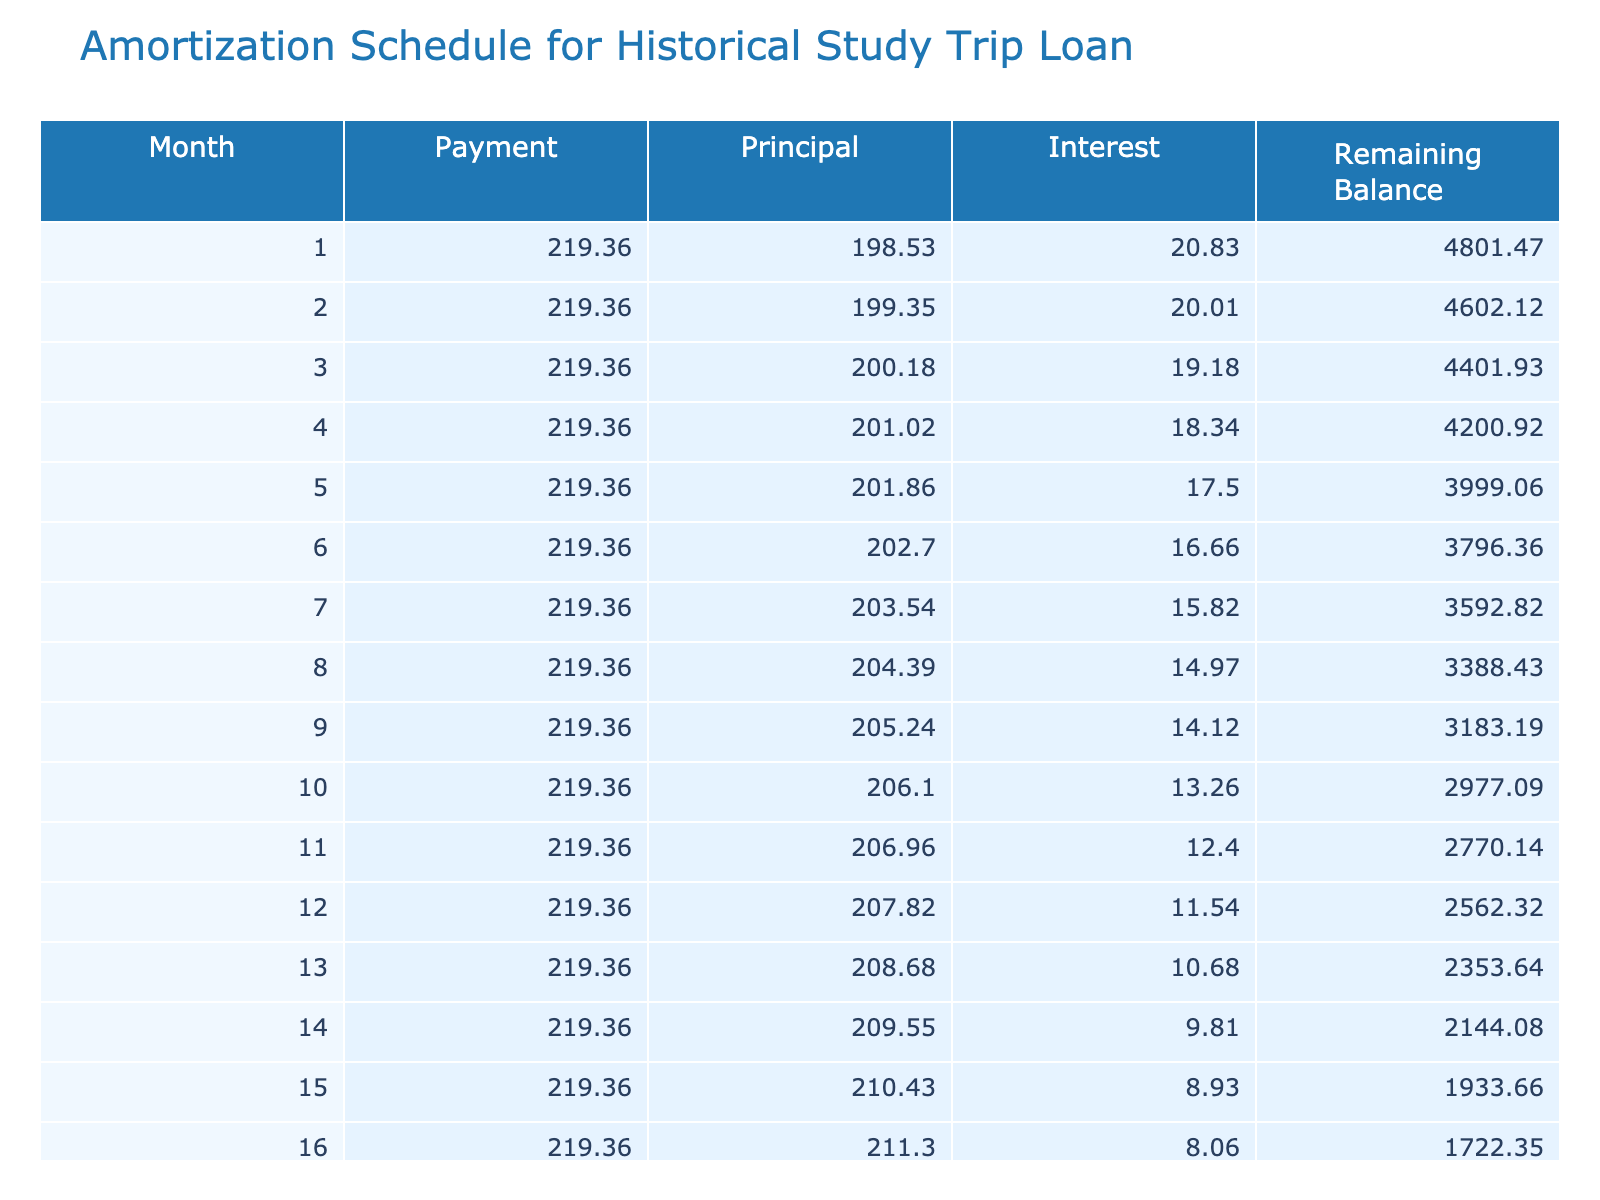What is the total amount of interest paid over the loan term? The total interest paid is directly stated in the table under the "Total Interest Paid" column. The value is 166.62.
Answer: 166.62 What will be the remaining balance after the 12th payment? To find the remaining balance after the 12th payment, we look at the corresponding month in the "Remaining Balance" column. The balance after the 12th payment is 1030.24.
Answer: 1030.24 How much of the monthly payment goes towards principal in the first month? We can see in the table that for the first month, the principal amount paid is listed under the "Principal" column. The value is 169.02.
Answer: 169.02 Is the loan amount more than the total payment amount? The loan amount is 5000 and the total payment amount is 5166.62. Since 5000 is less than 5166.62, the statement is false.
Answer: No What is the average monthly payment over the loan term? The monthly payment is a fixed value throughout the loan term, which is 219.36. Since this value is constant, the average is also 219.36.
Answer: 219.36 If the loan term were extended to 36 months, would the total interest paid increase? Extending the loan term typically means making smaller monthly payments while accruing more interest over time. Therefore, it is reasonable to conclude that the total interest would increase if the loan term were extended.
Answer: Yes What is the difference between the total payment and the loan amount? The total payment is 5166.62 and the loan amount is 5000. The difference is found by subtracting the loan amount from the total payment: 5166.62 - 5000 = 166.62.
Answer: 166.62 What is the principal payment total for the first year? The principal payments can be summed from the first 12 months. To find this, we need to refer to the "Principal" column for the first year, which sums to 1995.99.
Answer: 1995.99 What portion of the final payment goes to interest in the last month? To find the interest component of the last payment, we look at the "Interest" column corresponding to the last month, which is 0.43.
Answer: 0.43 